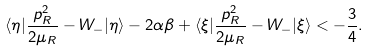Convert formula to latex. <formula><loc_0><loc_0><loc_500><loc_500>\langle \eta | \frac { { p } _ { R } ^ { 2 } } { 2 \mu _ { R } } - W _ { - } | \eta \rangle - 2 \alpha \beta + \langle \xi | \frac { { p } _ { R } ^ { 2 } } { 2 \mu _ { R } } - W _ { - } | \xi \rangle < - \frac { 3 } { 4 } .</formula> 